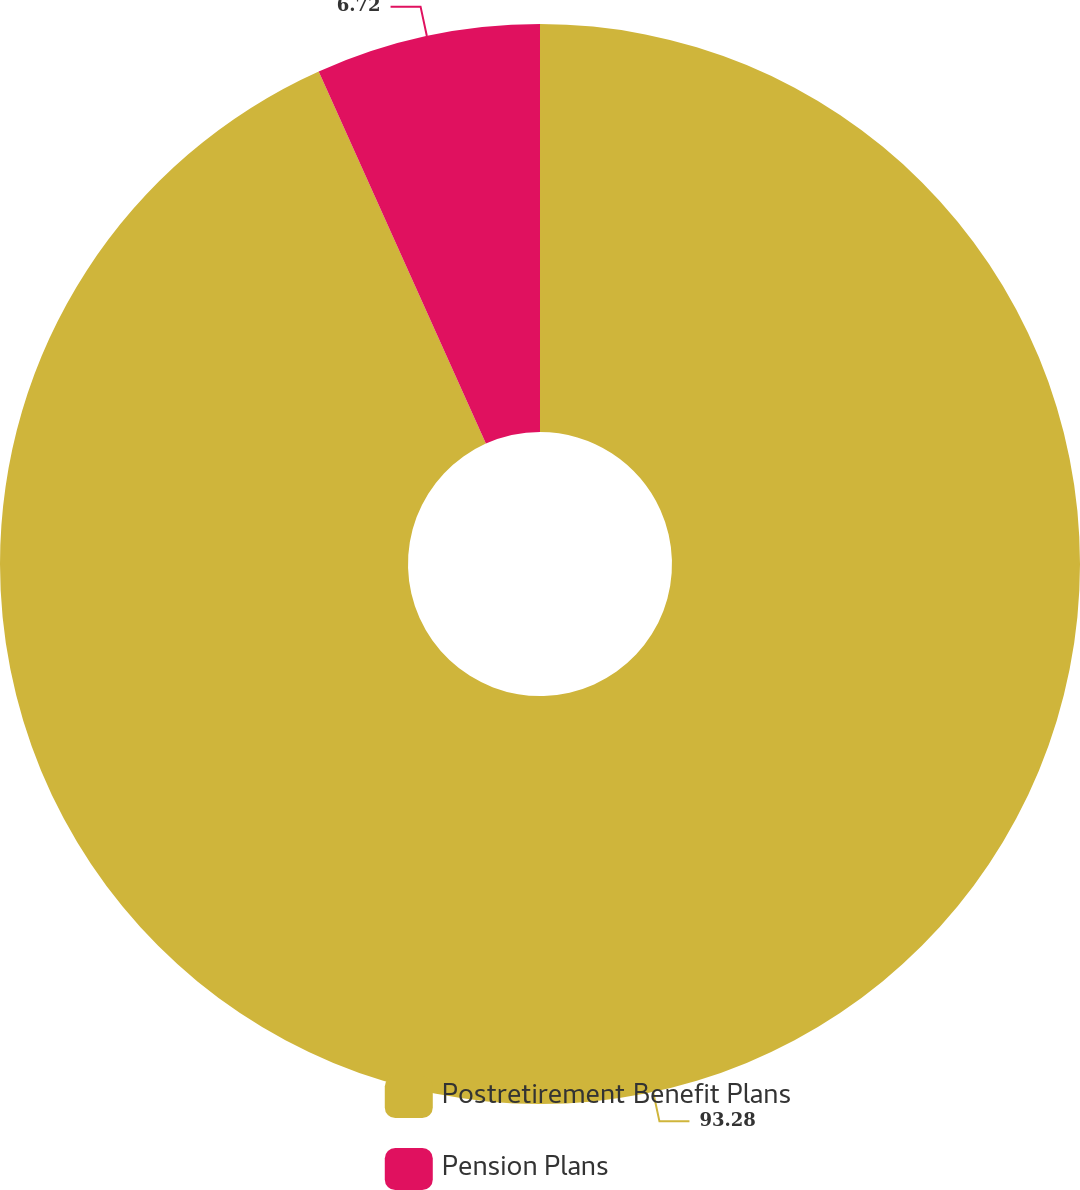Convert chart. <chart><loc_0><loc_0><loc_500><loc_500><pie_chart><fcel>Postretirement Benefit Plans<fcel>Pension Plans<nl><fcel>93.28%<fcel>6.72%<nl></chart> 